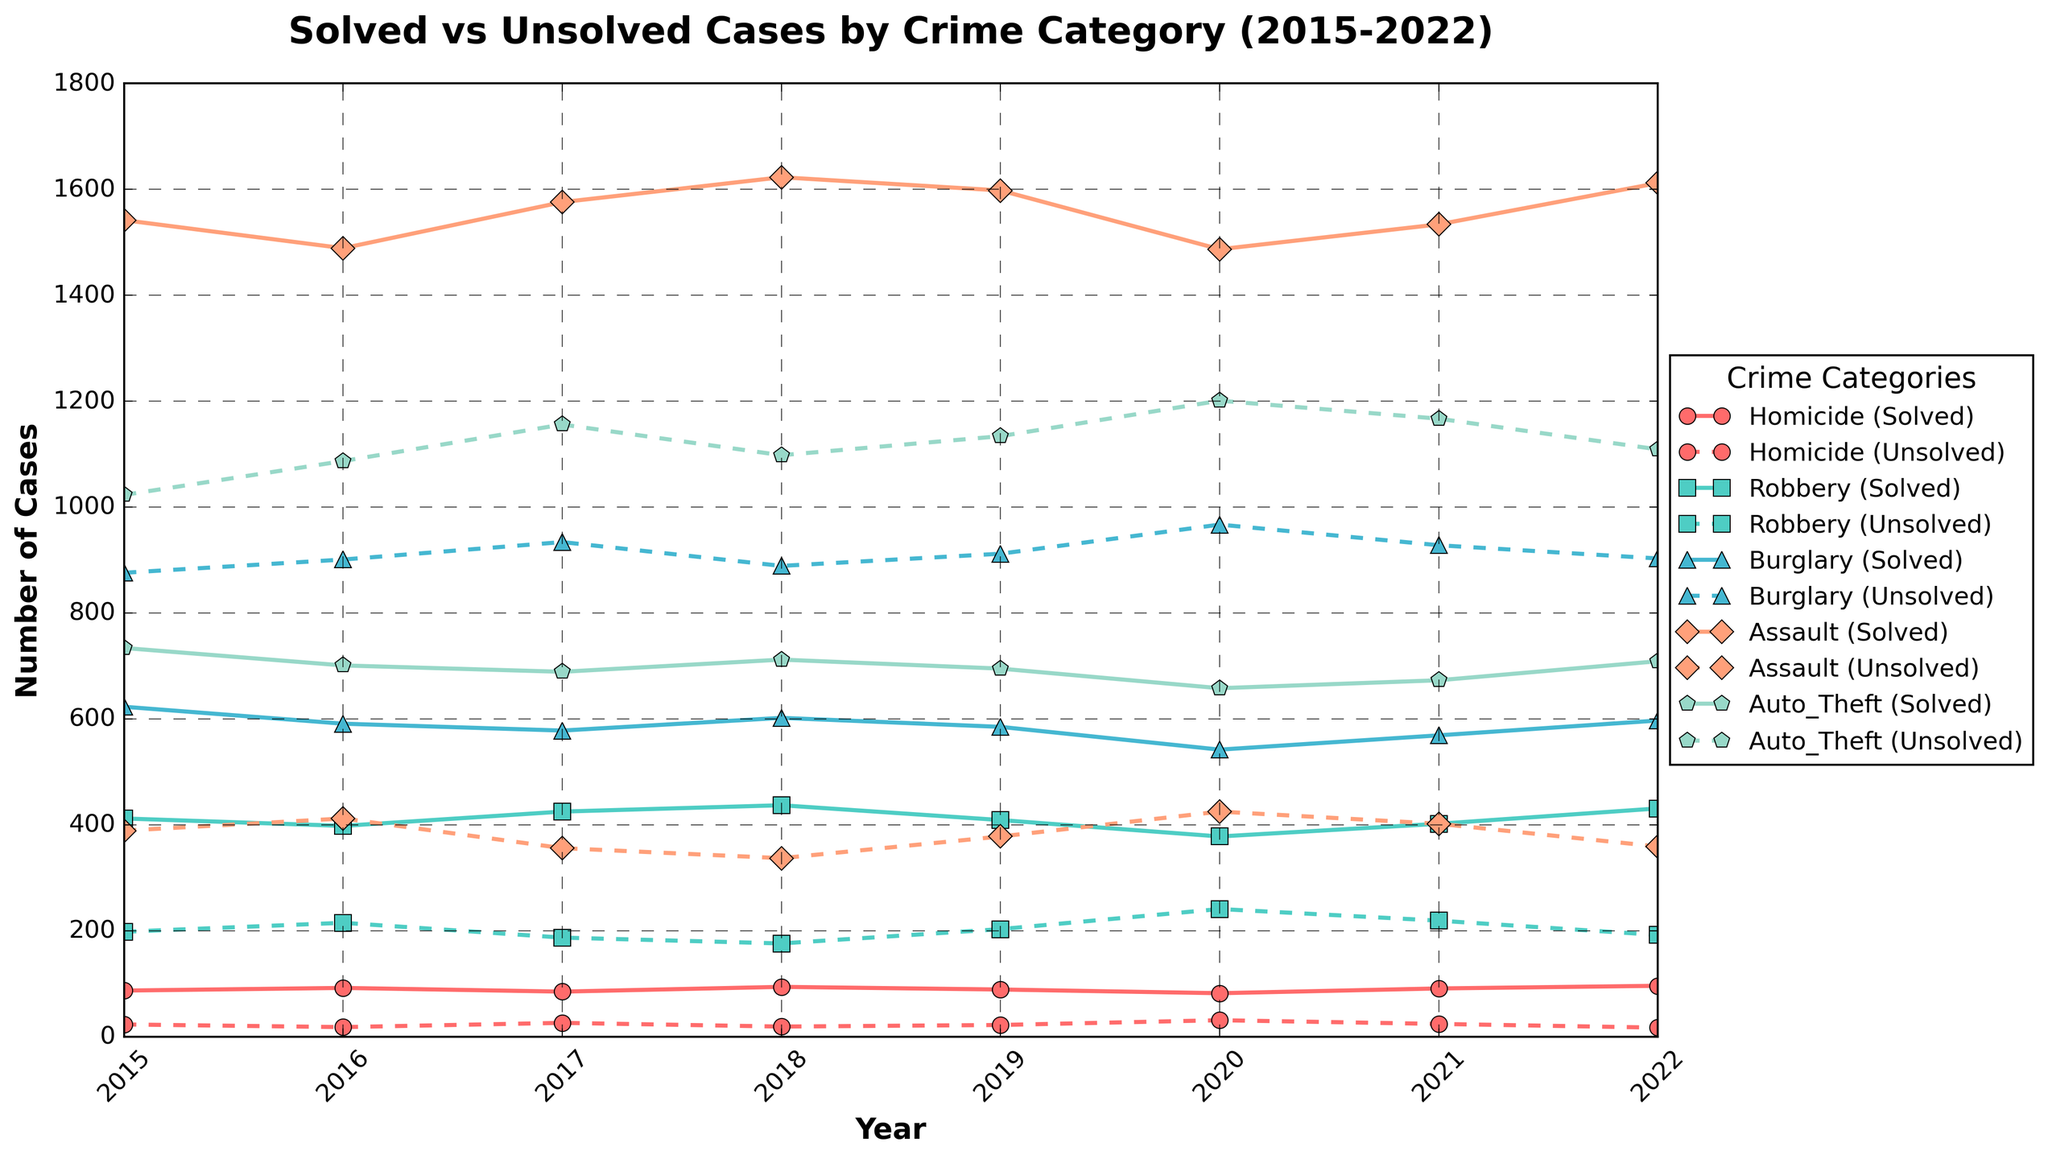Which crime category had the highest number of solved cases in 2020? Look at the solved cases for each crime category in the year 2020. Assault cases have the highest solved cases count at 1487.
Answer: Assault How did the number of unsolved robbery cases change from 2015 to 2022? Compare the number of unsolved robbery cases in 2015 and 2022. In 2015, there were 198 unsolved robbery cases, and in 2022, there were 192. The number decreased by 6 cases.
Answer: Decreased by 6 What is the average number of solved burglary cases from 2015 to 2022? Sum the number of solved burglary cases for each year (623 + 591 + 578 + 602 + 585 + 542 + 569 + 597) and divide by the number of years (8). The total is 4687, so the average is 4687 / 8 = 585.87
Answer: 585.87 Which year had the lowest number of solved homicide cases? Look at the solved homicide cases for each year and identify the year with the lowest value. The lowest number is 82 in the year 2020.
Answer: 2020 By how much did the number of unsolved auto theft cases increase from 2015 to 2020? Observe the unsolved auto theft cases in 2015 and 2020. In 2015, there were 1023 unsolved cases, and in 2020, there were 1201. The increase is 1201 - 1023 = 178 cases.
Answer: 178 Which crime category consistently had the most unsolved cases each year? For each year, compare the unsolved cases across all crime categories. Burglary consistently had more unsolved cases each year.
Answer: Burglary In which years did the number of solved assault cases exceed 1600? Examine the solved cases for assault in each year and identify the years that exceed 1600. This occurred in 2018 (1623), 2019 (1598, which didn't exceed), and 2022 (1612). Only 2018 and 2022 exceed 1600.
Answer: 2018, 2022 Which crime category showed the most significant reduction in solved cases from 2020 to 2021? Calculate the difference in solved cases for each crime category between 2020 and 2021. Subtractions are: Homicide (91-82 = 9), Robbery (402-378 = 24), Burglary (569-542 = 27), Assault (1534-1487 = 47), Auto Theft (673-658 = 15). The most significant reduction is in Assault with a drop of 47 cases.
Answer: Assault 